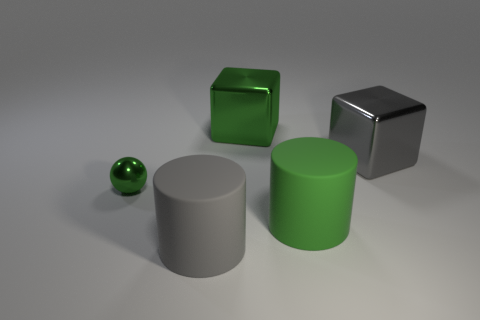There is a cylinder that is the same color as the sphere; what is it made of?
Provide a succinct answer. Rubber. How many cylinders are large green rubber objects or green things?
Give a very brief answer. 1. What number of green objects are the same size as the gray cylinder?
Your answer should be compact. 2. There is a matte object behind the gray cylinder; what number of big gray cylinders are on the right side of it?
Keep it short and to the point. 0. There is a object that is in front of the tiny green metal sphere and on the left side of the large green cube; how big is it?
Provide a short and direct response. Large. Are there more gray matte things than green objects?
Keep it short and to the point. No. Are there any rubber cylinders that have the same color as the metal sphere?
Ensure brevity in your answer.  Yes. There is a rubber cylinder to the left of the green shiny block; does it have the same size as the gray metal block?
Your response must be concise. Yes. Are there fewer gray rubber cylinders than large things?
Make the answer very short. Yes. Is there a big gray object made of the same material as the big green block?
Provide a short and direct response. Yes. 